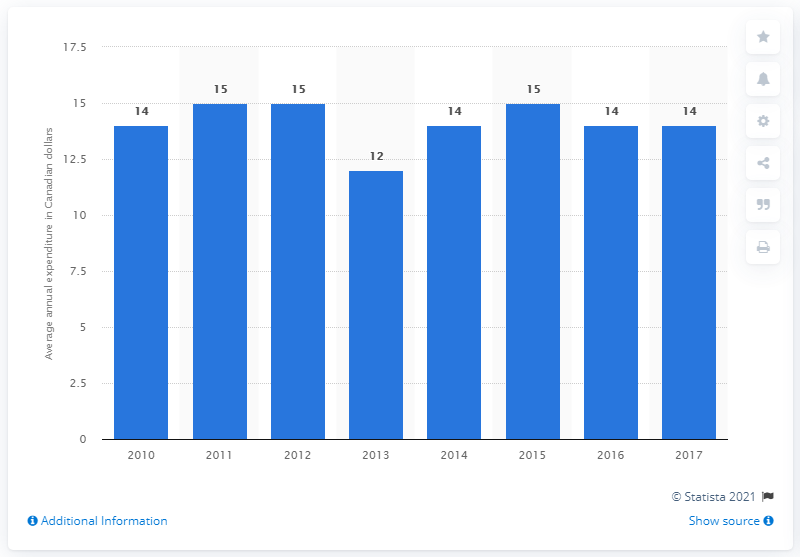How does the expenditure in 2017 compare with that in 2010? In 2017, the expenditure was 14 Canadian dollars, which is consistent with the expenditure of 14 dollars observed in 2010, indicating no significant change over this seven-year period. What does this consistency suggest about market conditions for microwave ovens? This consistency in expenditure suggests that the market for microwave ovens has been stable, with steady demand and pricing over the years. 